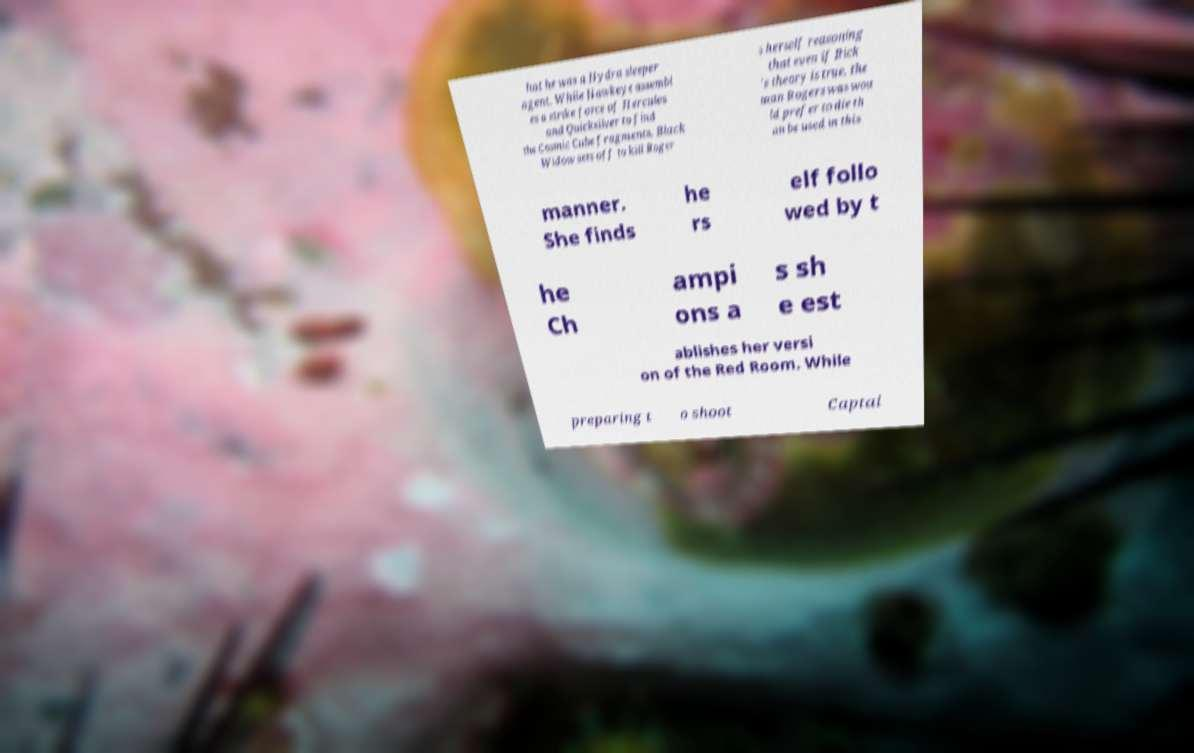I need the written content from this picture converted into text. Can you do that? hat he was a Hydra sleeper agent. While Hawkeye assembl es a strike force of Hercules and Quicksilver to find the Cosmic Cube fragments, Black Widow sets off to kill Roger s herself reasoning that even if Rick 's theory is true, the man Rogers was wou ld prefer to die th an be used in this manner. She finds he rs elf follo wed by t he Ch ampi ons a s sh e est ablishes her versi on of the Red Room. While preparing t o shoot Captai 